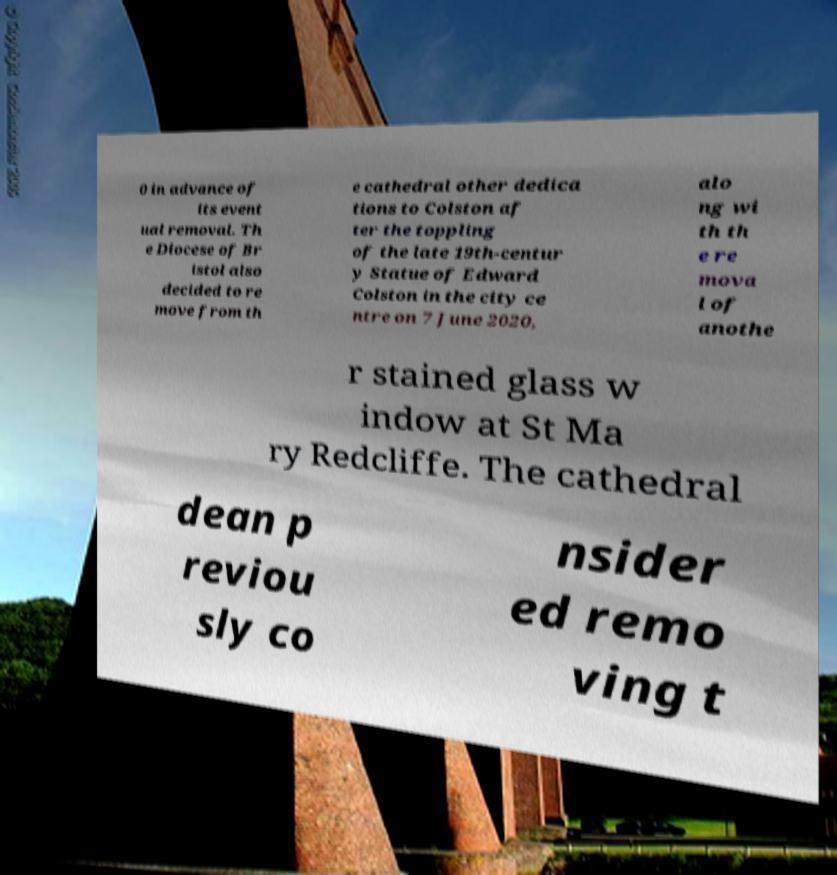Could you assist in decoding the text presented in this image and type it out clearly? 0 in advance of its event ual removal. Th e Diocese of Br istol also decided to re move from th e cathedral other dedica tions to Colston af ter the toppling of the late 19th-centur y Statue of Edward Colston in the city ce ntre on 7 June 2020, alo ng wi th th e re mova l of anothe r stained glass w indow at St Ma ry Redcliffe. The cathedral dean p reviou sly co nsider ed remo ving t 